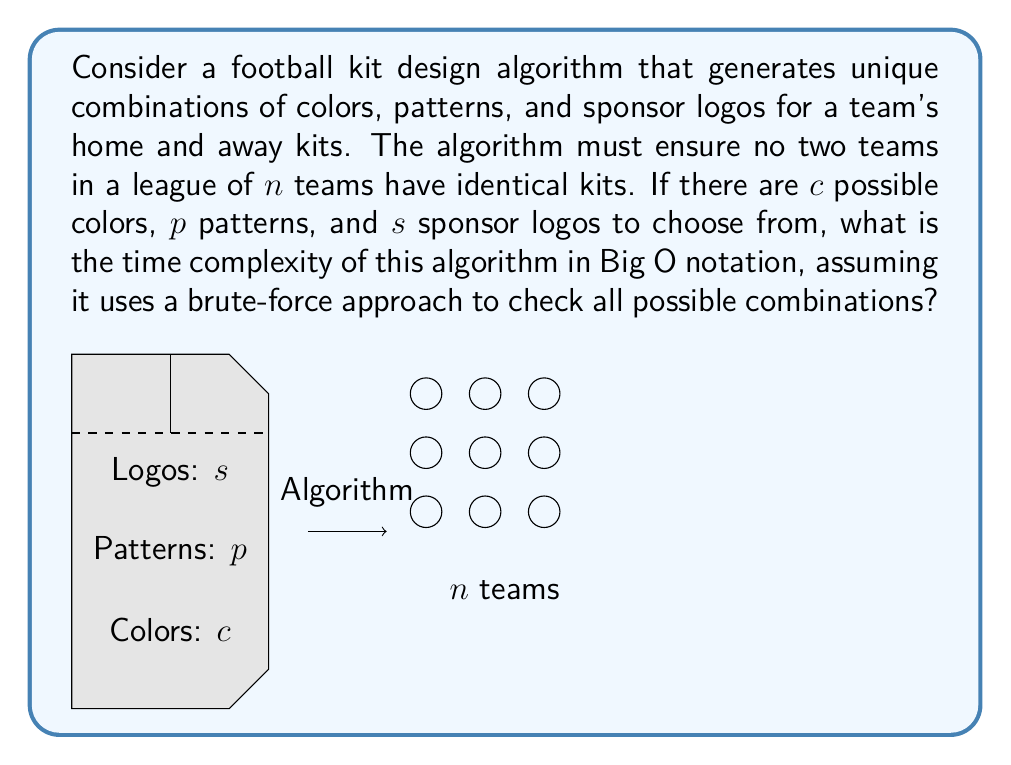Show me your answer to this math problem. Let's break this down step-by-step:

1) First, we need to calculate the total number of possible kit combinations:
   - For each kit (home and away), we have $c$ color choices, $p$ pattern choices, and $s$ logo choices.
   - The total number of combinations for one kit is therefore $c \times p \times s$.
   - Since we need both home and away kits, the total number of combinations for a team is $(c \times p \times s)^2$.

2) Now, for $n$ teams, we need to ensure that no two teams have the same combination. This is equivalent to choosing $n$ distinct items from $(c \times p \times s)^2$ possibilities.

3) A brute-force approach would generate all possible combinations and check each one against all previously generated combinations to ensure uniqueness.

4) The number of comparisons needed in the worst case scenario is:
   $1 + 2 + 3 + ... + (n-1) = \frac{n(n-1)}{2}$

5) For each comparison, we need to check both home and away kits, which involves comparing $2(c + p + s)$ elements (assuming we compare colors, patterns, and logos separately for efficiency).

6) Therefore, the total number of operations is proportional to:
   $n \times \frac{n(n-1)}{2} \times 2(c + p + s) = n^2(n-1)(c + p + s)$

7) In Big O notation, we ignore constants and lower-order terms, so this simplifies to $O(n^3)$.

Note: This assumes that $c$, $p$, and $s$ are constants and much smaller than $n$. If they are variables that can grow with $n$, the complexity would be different.
Answer: $O(n^3)$ 